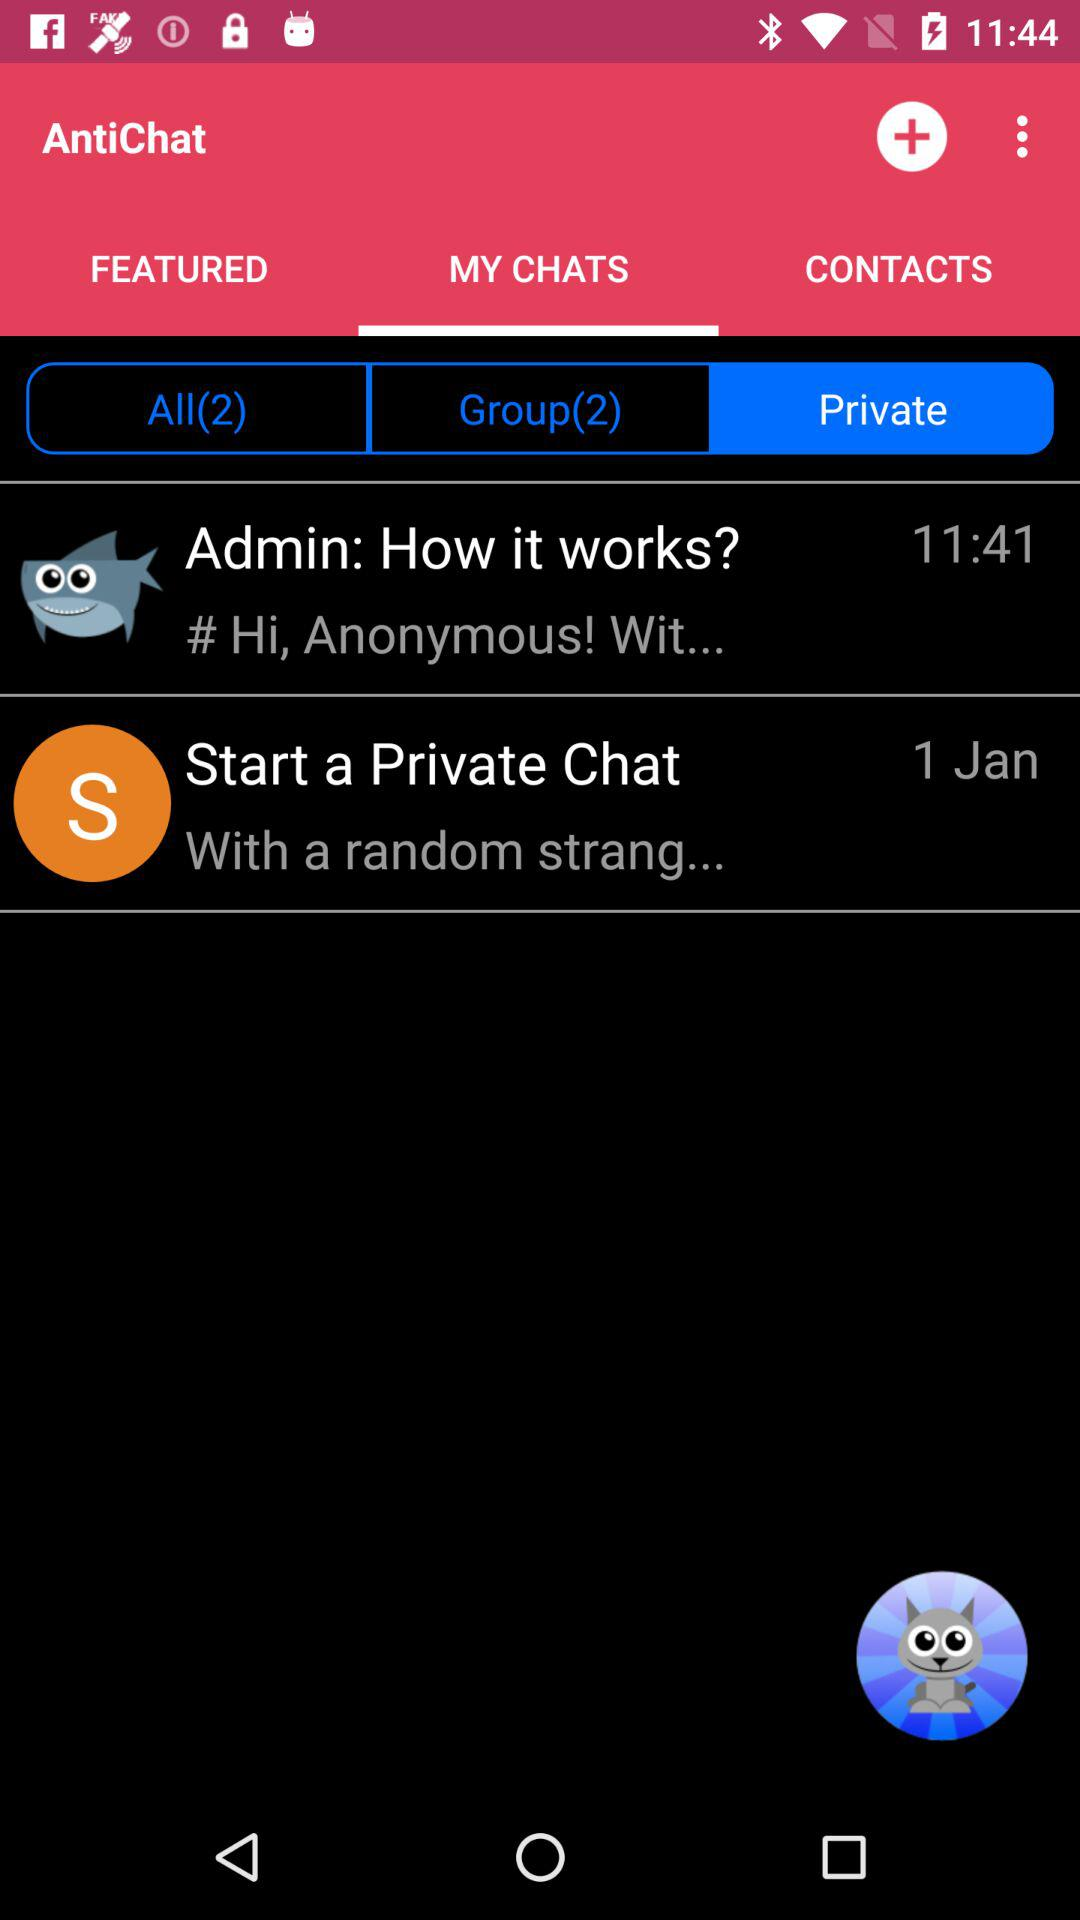How many unread chats are there in "All"? There are 2 unread chats in "All". 